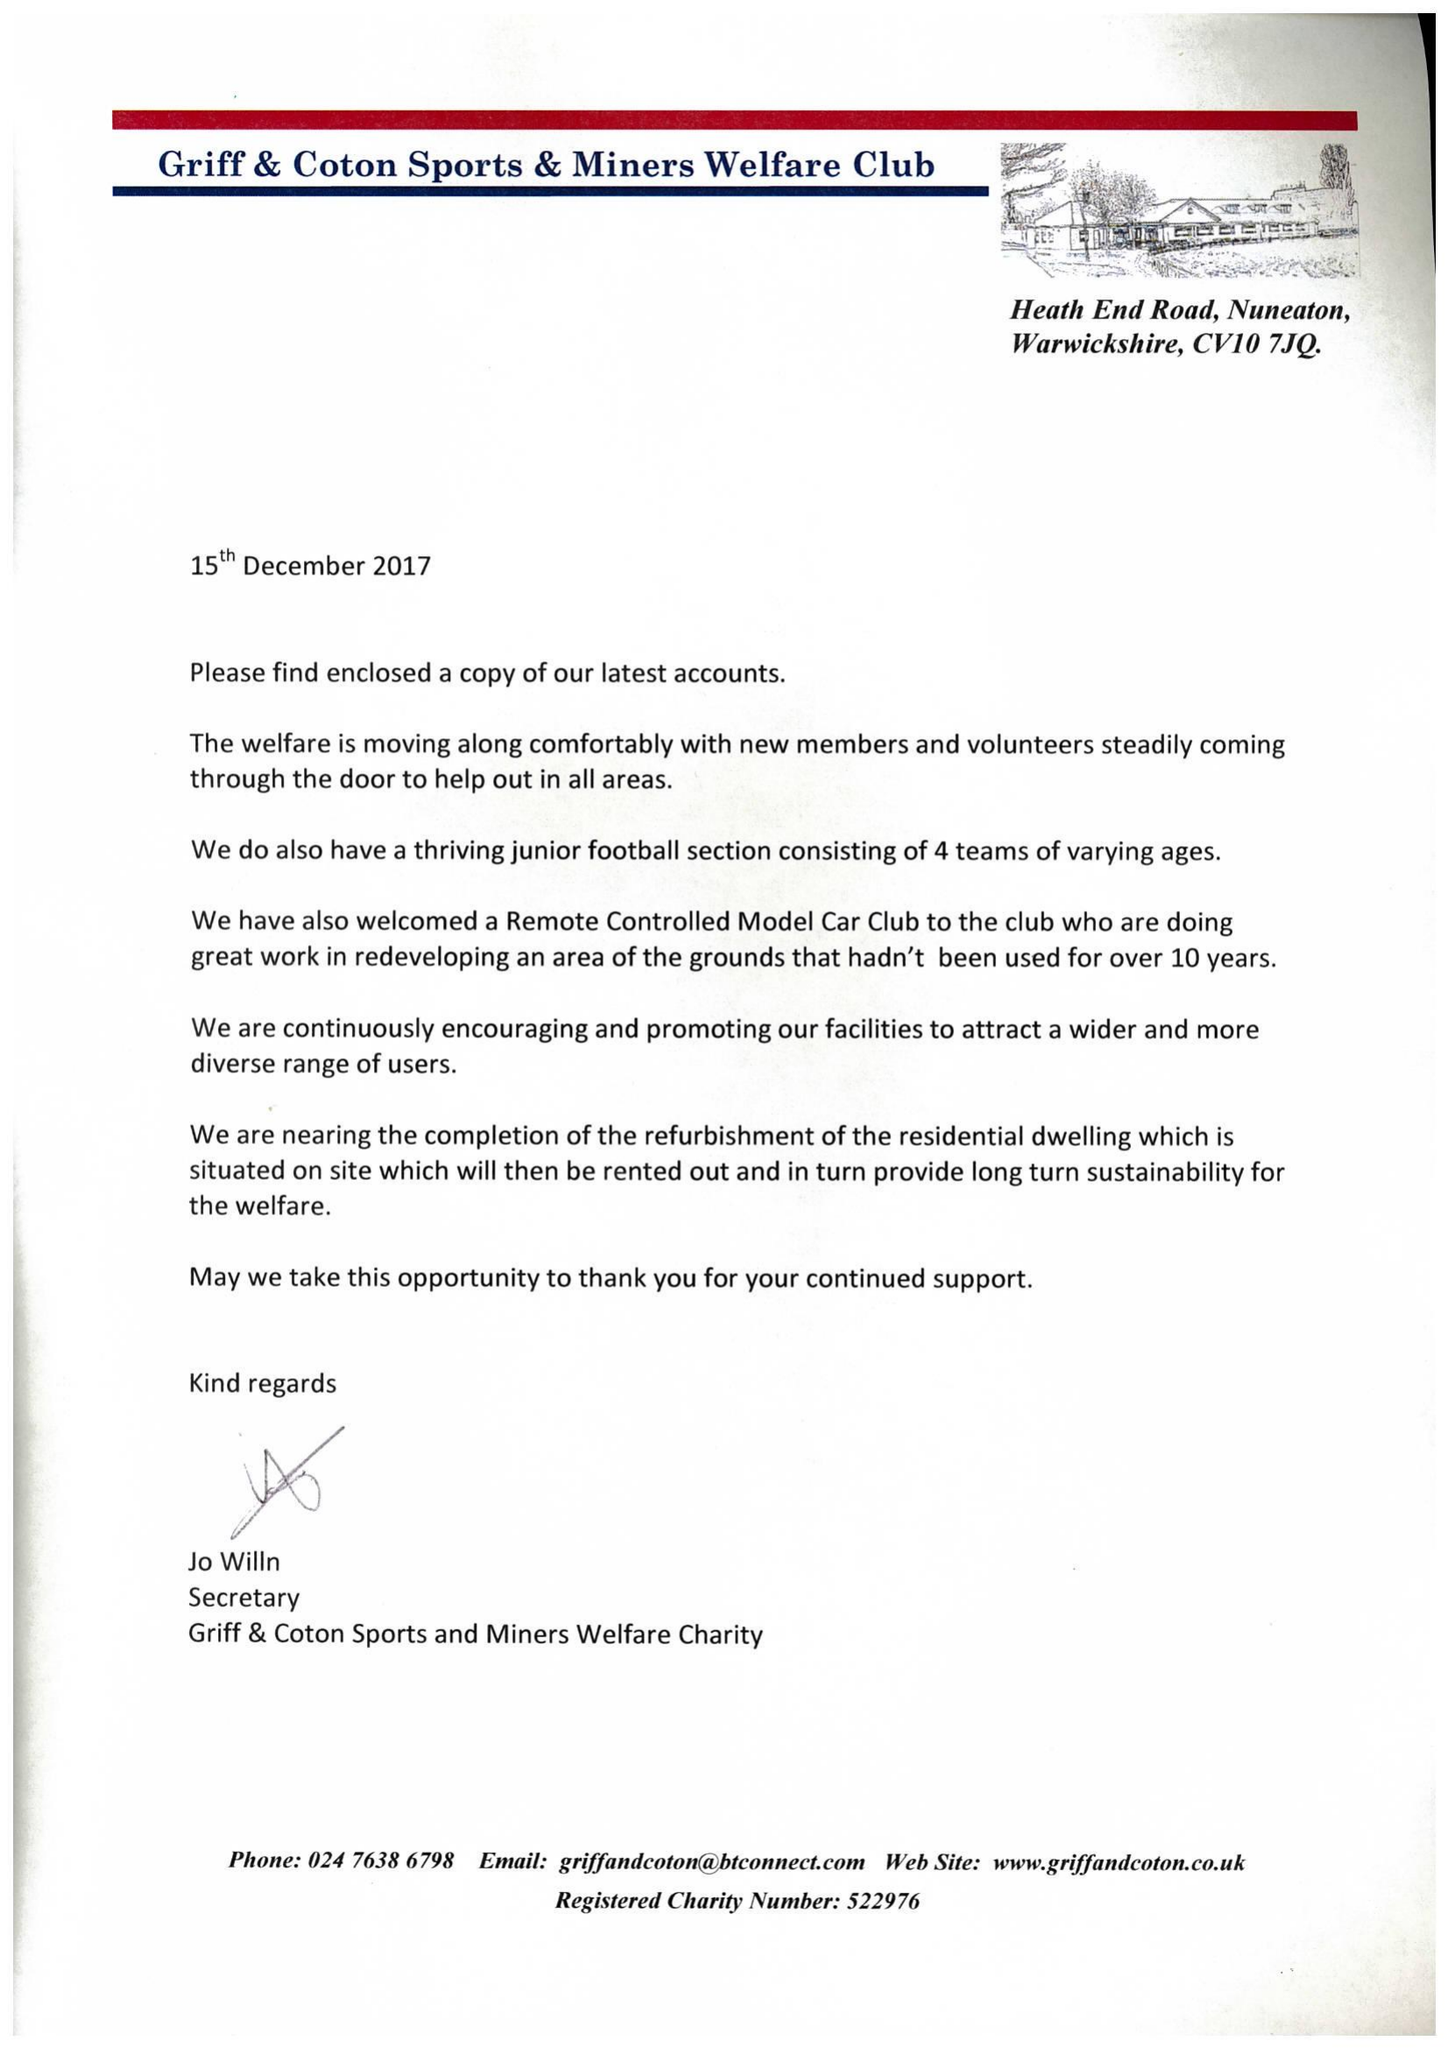What is the value for the address__street_line?
Answer the question using a single word or phrase. HEATH END ROAD 